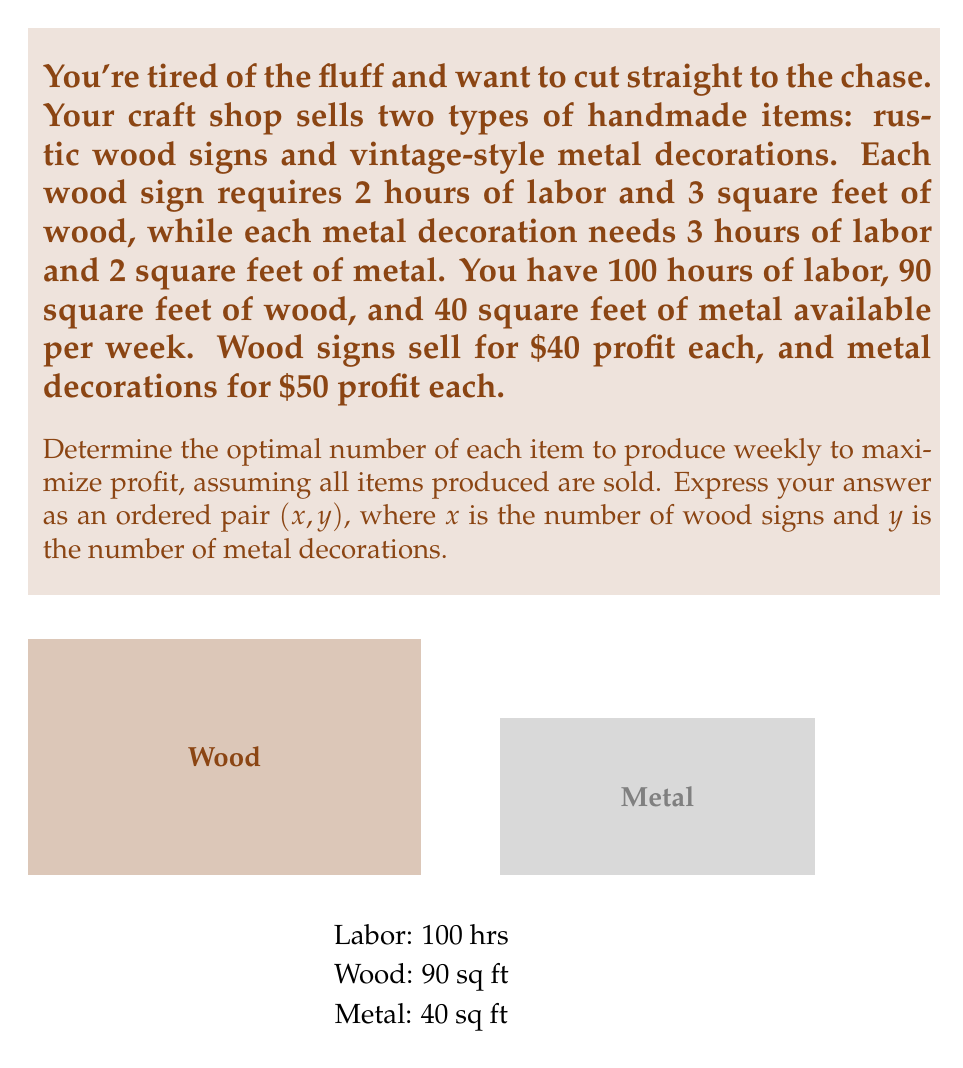Solve this math problem. Let's approach this problem using linear programming:

1) Define variables:
   $x$ = number of wood signs
   $y$ = number of metal decorations

2) Objective function (profit):
   Maximize $Z = 40x + 50y$

3) Constraints:
   Labor: $2x + 3y \leq 100$
   Wood: $3x \leq 90$
   Metal: $2y \leq 40$
   Non-negativity: $x \geq 0, y \geq 0$

4) Simplify constraints:
   $2x + 3y \leq 100$
   $x \leq 30$
   $y \leq 20$

5) Plot constraints:
   [asy]
   unitsize(0.2cm);
   draw((0,0)--(50,0)--(50,35)--(0,35)--cycle);
   draw((0,0)--(50,0), arrow=Arrow(TeXHead));
   draw((0,0)--(0,35), arrow=Arrow(TeXHead));
   label("x", (52,0));
   label("y", (0,37));
   draw((0,33.33)--(50,0), blue);
   draw((30,0)--(30,35), red);
   draw((0,20)--(50,20), green);
   label("2x + 3y = 100", (45,5), blue);
   label("x = 30", (32,2), red);
   label("y = 20", (45,22), green);
   fill((0,0)--(30,0)--(30,20)--(20,20)--(0,33.33)--cycle, gray(0.9));
   [/asy]

6) Identify corner points of the feasible region:
   (0,0), (30,0), (30,13.33), (20,20), (0,33.33)

7) Evaluate objective function at each point:
   (0,0): Z = 0
   (30,0): Z = 1200
   (30,13.33): Z = 1866.67
   (20,20): Z = 1800
   (0,33.33): Z = 1666.67

8) The maximum value occurs at (30,13.33), but we need integer solutions.
   Therefore, we check the nearby integer points:
   (30,13): Z = 1850
   (30,14): Z = 1900

The optimal integer solution is (30,14).
Answer: (30,14) 